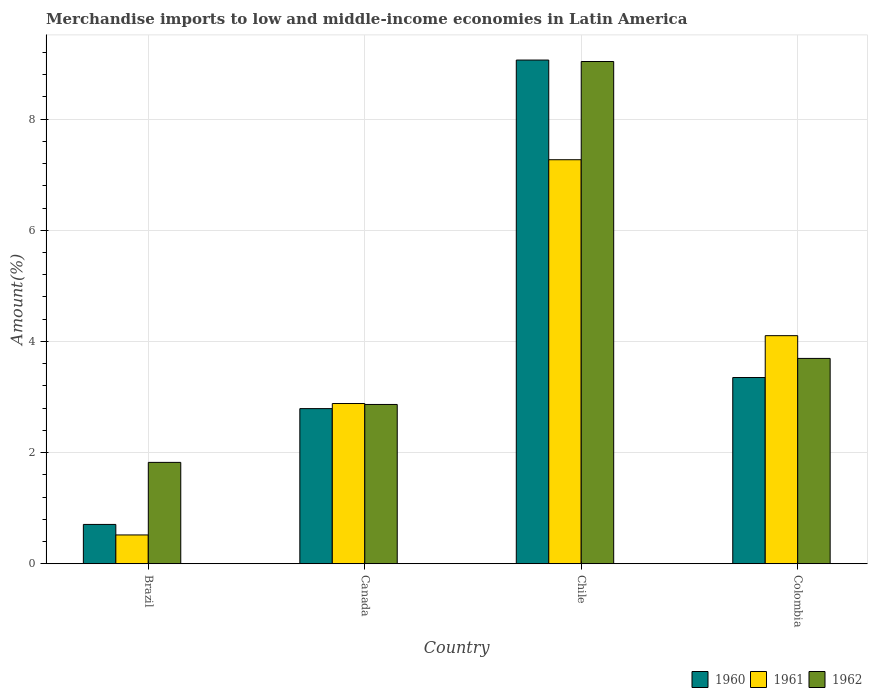How many different coloured bars are there?
Provide a succinct answer. 3. Are the number of bars per tick equal to the number of legend labels?
Your answer should be very brief. Yes. Are the number of bars on each tick of the X-axis equal?
Ensure brevity in your answer.  Yes. How many bars are there on the 1st tick from the right?
Keep it short and to the point. 3. What is the percentage of amount earned from merchandise imports in 1961 in Canada?
Give a very brief answer. 2.88. Across all countries, what is the maximum percentage of amount earned from merchandise imports in 1960?
Your response must be concise. 9.06. Across all countries, what is the minimum percentage of amount earned from merchandise imports in 1962?
Make the answer very short. 1.82. In which country was the percentage of amount earned from merchandise imports in 1961 maximum?
Provide a short and direct response. Chile. What is the total percentage of amount earned from merchandise imports in 1960 in the graph?
Provide a succinct answer. 15.91. What is the difference between the percentage of amount earned from merchandise imports in 1962 in Brazil and that in Chile?
Give a very brief answer. -7.21. What is the difference between the percentage of amount earned from merchandise imports in 1961 in Colombia and the percentage of amount earned from merchandise imports in 1960 in Brazil?
Offer a terse response. 3.4. What is the average percentage of amount earned from merchandise imports in 1962 per country?
Ensure brevity in your answer.  4.35. What is the difference between the percentage of amount earned from merchandise imports of/in 1962 and percentage of amount earned from merchandise imports of/in 1960 in Canada?
Your answer should be compact. 0.07. In how many countries, is the percentage of amount earned from merchandise imports in 1962 greater than 1.6 %?
Your response must be concise. 4. What is the ratio of the percentage of amount earned from merchandise imports in 1960 in Brazil to that in Chile?
Your response must be concise. 0.08. What is the difference between the highest and the second highest percentage of amount earned from merchandise imports in 1962?
Offer a very short reply. 6.17. What is the difference between the highest and the lowest percentage of amount earned from merchandise imports in 1960?
Your response must be concise. 8.35. What does the 1st bar from the right in Chile represents?
Provide a short and direct response. 1962. Is it the case that in every country, the sum of the percentage of amount earned from merchandise imports in 1960 and percentage of amount earned from merchandise imports in 1961 is greater than the percentage of amount earned from merchandise imports in 1962?
Make the answer very short. No. What is the difference between two consecutive major ticks on the Y-axis?
Offer a very short reply. 2. Are the values on the major ticks of Y-axis written in scientific E-notation?
Provide a short and direct response. No. Does the graph contain any zero values?
Make the answer very short. No. Does the graph contain grids?
Your response must be concise. Yes. Where does the legend appear in the graph?
Provide a short and direct response. Bottom right. How many legend labels are there?
Your answer should be very brief. 3. What is the title of the graph?
Make the answer very short. Merchandise imports to low and middle-income economies in Latin America. Does "1964" appear as one of the legend labels in the graph?
Your answer should be very brief. No. What is the label or title of the X-axis?
Make the answer very short. Country. What is the label or title of the Y-axis?
Make the answer very short. Amount(%). What is the Amount(%) in 1960 in Brazil?
Give a very brief answer. 0.71. What is the Amount(%) of 1961 in Brazil?
Your answer should be compact. 0.52. What is the Amount(%) of 1962 in Brazil?
Your answer should be very brief. 1.82. What is the Amount(%) in 1960 in Canada?
Ensure brevity in your answer.  2.79. What is the Amount(%) in 1961 in Canada?
Offer a very short reply. 2.88. What is the Amount(%) in 1962 in Canada?
Provide a succinct answer. 2.87. What is the Amount(%) of 1960 in Chile?
Give a very brief answer. 9.06. What is the Amount(%) in 1961 in Chile?
Make the answer very short. 7.27. What is the Amount(%) in 1962 in Chile?
Offer a terse response. 9.04. What is the Amount(%) of 1960 in Colombia?
Provide a succinct answer. 3.35. What is the Amount(%) of 1961 in Colombia?
Offer a terse response. 4.1. What is the Amount(%) of 1962 in Colombia?
Provide a short and direct response. 3.69. Across all countries, what is the maximum Amount(%) in 1960?
Keep it short and to the point. 9.06. Across all countries, what is the maximum Amount(%) of 1961?
Keep it short and to the point. 7.27. Across all countries, what is the maximum Amount(%) in 1962?
Offer a very short reply. 9.04. Across all countries, what is the minimum Amount(%) in 1960?
Your answer should be very brief. 0.71. Across all countries, what is the minimum Amount(%) of 1961?
Keep it short and to the point. 0.52. Across all countries, what is the minimum Amount(%) of 1962?
Your answer should be very brief. 1.82. What is the total Amount(%) in 1960 in the graph?
Offer a terse response. 15.91. What is the total Amount(%) in 1961 in the graph?
Your answer should be compact. 14.77. What is the total Amount(%) of 1962 in the graph?
Your answer should be compact. 17.42. What is the difference between the Amount(%) of 1960 in Brazil and that in Canada?
Offer a terse response. -2.08. What is the difference between the Amount(%) in 1961 in Brazil and that in Canada?
Give a very brief answer. -2.36. What is the difference between the Amount(%) of 1962 in Brazil and that in Canada?
Ensure brevity in your answer.  -1.04. What is the difference between the Amount(%) in 1960 in Brazil and that in Chile?
Your answer should be very brief. -8.35. What is the difference between the Amount(%) of 1961 in Brazil and that in Chile?
Provide a succinct answer. -6.75. What is the difference between the Amount(%) in 1962 in Brazil and that in Chile?
Your response must be concise. -7.21. What is the difference between the Amount(%) in 1960 in Brazil and that in Colombia?
Your answer should be compact. -2.64. What is the difference between the Amount(%) in 1961 in Brazil and that in Colombia?
Keep it short and to the point. -3.59. What is the difference between the Amount(%) of 1962 in Brazil and that in Colombia?
Provide a short and direct response. -1.87. What is the difference between the Amount(%) of 1960 in Canada and that in Chile?
Your answer should be compact. -6.27. What is the difference between the Amount(%) in 1961 in Canada and that in Chile?
Offer a very short reply. -4.39. What is the difference between the Amount(%) in 1962 in Canada and that in Chile?
Make the answer very short. -6.17. What is the difference between the Amount(%) in 1960 in Canada and that in Colombia?
Your response must be concise. -0.56. What is the difference between the Amount(%) in 1961 in Canada and that in Colombia?
Offer a terse response. -1.22. What is the difference between the Amount(%) of 1962 in Canada and that in Colombia?
Your response must be concise. -0.83. What is the difference between the Amount(%) of 1960 in Chile and that in Colombia?
Make the answer very short. 5.71. What is the difference between the Amount(%) in 1961 in Chile and that in Colombia?
Give a very brief answer. 3.17. What is the difference between the Amount(%) in 1962 in Chile and that in Colombia?
Provide a short and direct response. 5.34. What is the difference between the Amount(%) of 1960 in Brazil and the Amount(%) of 1961 in Canada?
Offer a terse response. -2.18. What is the difference between the Amount(%) of 1960 in Brazil and the Amount(%) of 1962 in Canada?
Give a very brief answer. -2.16. What is the difference between the Amount(%) in 1961 in Brazil and the Amount(%) in 1962 in Canada?
Your response must be concise. -2.35. What is the difference between the Amount(%) of 1960 in Brazil and the Amount(%) of 1961 in Chile?
Your answer should be compact. -6.56. What is the difference between the Amount(%) of 1960 in Brazil and the Amount(%) of 1962 in Chile?
Provide a succinct answer. -8.33. What is the difference between the Amount(%) of 1961 in Brazil and the Amount(%) of 1962 in Chile?
Ensure brevity in your answer.  -8.52. What is the difference between the Amount(%) in 1960 in Brazil and the Amount(%) in 1961 in Colombia?
Give a very brief answer. -3.4. What is the difference between the Amount(%) in 1960 in Brazil and the Amount(%) in 1962 in Colombia?
Offer a terse response. -2.99. What is the difference between the Amount(%) of 1961 in Brazil and the Amount(%) of 1962 in Colombia?
Make the answer very short. -3.18. What is the difference between the Amount(%) in 1960 in Canada and the Amount(%) in 1961 in Chile?
Make the answer very short. -4.48. What is the difference between the Amount(%) in 1960 in Canada and the Amount(%) in 1962 in Chile?
Your answer should be very brief. -6.25. What is the difference between the Amount(%) of 1961 in Canada and the Amount(%) of 1962 in Chile?
Provide a short and direct response. -6.15. What is the difference between the Amount(%) in 1960 in Canada and the Amount(%) in 1961 in Colombia?
Make the answer very short. -1.31. What is the difference between the Amount(%) of 1960 in Canada and the Amount(%) of 1962 in Colombia?
Make the answer very short. -0.9. What is the difference between the Amount(%) in 1961 in Canada and the Amount(%) in 1962 in Colombia?
Your response must be concise. -0.81. What is the difference between the Amount(%) of 1960 in Chile and the Amount(%) of 1961 in Colombia?
Make the answer very short. 4.96. What is the difference between the Amount(%) in 1960 in Chile and the Amount(%) in 1962 in Colombia?
Your answer should be very brief. 5.37. What is the difference between the Amount(%) of 1961 in Chile and the Amount(%) of 1962 in Colombia?
Provide a succinct answer. 3.57. What is the average Amount(%) in 1960 per country?
Ensure brevity in your answer.  3.98. What is the average Amount(%) of 1961 per country?
Provide a short and direct response. 3.69. What is the average Amount(%) in 1962 per country?
Give a very brief answer. 4.35. What is the difference between the Amount(%) of 1960 and Amount(%) of 1961 in Brazil?
Give a very brief answer. 0.19. What is the difference between the Amount(%) of 1960 and Amount(%) of 1962 in Brazil?
Your response must be concise. -1.12. What is the difference between the Amount(%) in 1961 and Amount(%) in 1962 in Brazil?
Offer a very short reply. -1.31. What is the difference between the Amount(%) of 1960 and Amount(%) of 1961 in Canada?
Your response must be concise. -0.09. What is the difference between the Amount(%) in 1960 and Amount(%) in 1962 in Canada?
Provide a short and direct response. -0.07. What is the difference between the Amount(%) of 1961 and Amount(%) of 1962 in Canada?
Make the answer very short. 0.02. What is the difference between the Amount(%) in 1960 and Amount(%) in 1961 in Chile?
Keep it short and to the point. 1.79. What is the difference between the Amount(%) of 1960 and Amount(%) of 1962 in Chile?
Give a very brief answer. 0.03. What is the difference between the Amount(%) in 1961 and Amount(%) in 1962 in Chile?
Your answer should be very brief. -1.77. What is the difference between the Amount(%) in 1960 and Amount(%) in 1961 in Colombia?
Your answer should be compact. -0.75. What is the difference between the Amount(%) of 1960 and Amount(%) of 1962 in Colombia?
Ensure brevity in your answer.  -0.34. What is the difference between the Amount(%) of 1961 and Amount(%) of 1962 in Colombia?
Your answer should be very brief. 0.41. What is the ratio of the Amount(%) in 1960 in Brazil to that in Canada?
Offer a very short reply. 0.25. What is the ratio of the Amount(%) in 1961 in Brazil to that in Canada?
Your answer should be very brief. 0.18. What is the ratio of the Amount(%) of 1962 in Brazil to that in Canada?
Your answer should be compact. 0.64. What is the ratio of the Amount(%) of 1960 in Brazil to that in Chile?
Give a very brief answer. 0.08. What is the ratio of the Amount(%) of 1961 in Brazil to that in Chile?
Keep it short and to the point. 0.07. What is the ratio of the Amount(%) of 1962 in Brazil to that in Chile?
Keep it short and to the point. 0.2. What is the ratio of the Amount(%) in 1960 in Brazil to that in Colombia?
Your response must be concise. 0.21. What is the ratio of the Amount(%) of 1961 in Brazil to that in Colombia?
Your response must be concise. 0.13. What is the ratio of the Amount(%) of 1962 in Brazil to that in Colombia?
Your answer should be very brief. 0.49. What is the ratio of the Amount(%) in 1960 in Canada to that in Chile?
Offer a very short reply. 0.31. What is the ratio of the Amount(%) in 1961 in Canada to that in Chile?
Ensure brevity in your answer.  0.4. What is the ratio of the Amount(%) in 1962 in Canada to that in Chile?
Offer a terse response. 0.32. What is the ratio of the Amount(%) in 1960 in Canada to that in Colombia?
Offer a terse response. 0.83. What is the ratio of the Amount(%) in 1961 in Canada to that in Colombia?
Make the answer very short. 0.7. What is the ratio of the Amount(%) of 1962 in Canada to that in Colombia?
Your response must be concise. 0.78. What is the ratio of the Amount(%) of 1960 in Chile to that in Colombia?
Offer a very short reply. 2.7. What is the ratio of the Amount(%) in 1961 in Chile to that in Colombia?
Your response must be concise. 1.77. What is the ratio of the Amount(%) in 1962 in Chile to that in Colombia?
Provide a short and direct response. 2.45. What is the difference between the highest and the second highest Amount(%) in 1960?
Your answer should be compact. 5.71. What is the difference between the highest and the second highest Amount(%) in 1961?
Give a very brief answer. 3.17. What is the difference between the highest and the second highest Amount(%) in 1962?
Give a very brief answer. 5.34. What is the difference between the highest and the lowest Amount(%) in 1960?
Offer a very short reply. 8.35. What is the difference between the highest and the lowest Amount(%) in 1961?
Offer a terse response. 6.75. What is the difference between the highest and the lowest Amount(%) in 1962?
Offer a terse response. 7.21. 